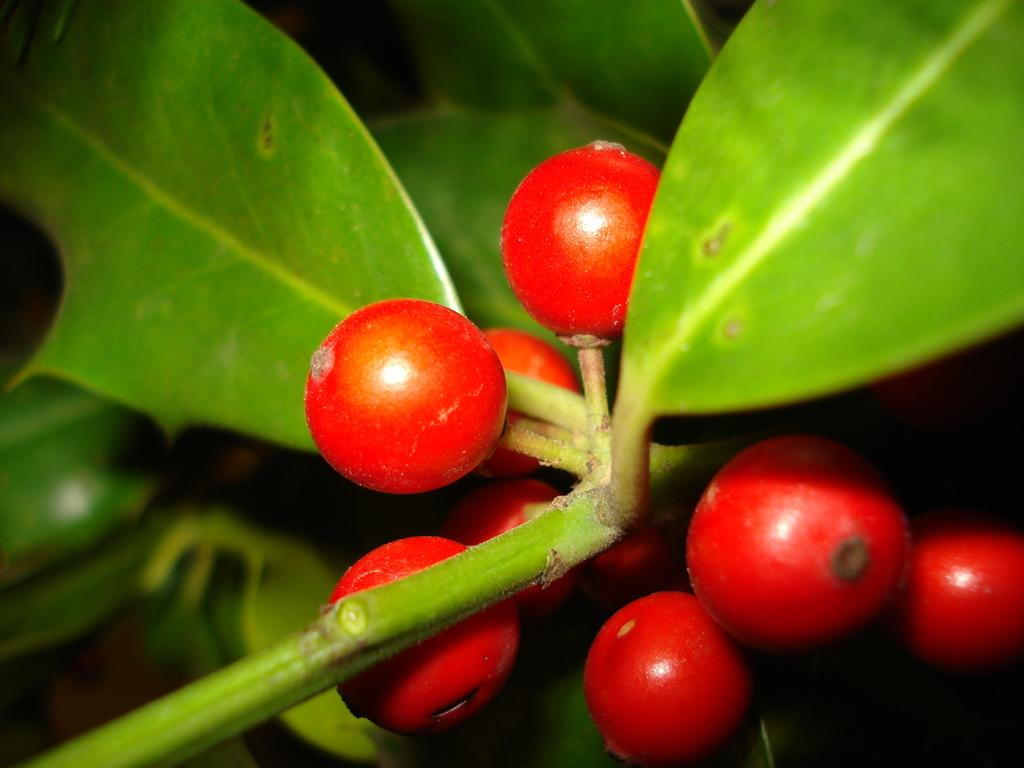What type of fruit is visible in the image? There is a berry in the image. What color is the berry? The berry is red in color. What else can be seen in the image besides the berry? There are leaves in the image. Is there a chain attached to the berry in the image? No, there is no chain present in the image. What type of poison is associated with the berry in the image? There is no mention of poison in the image, and the berry's safety cannot be determined from the image alone. 